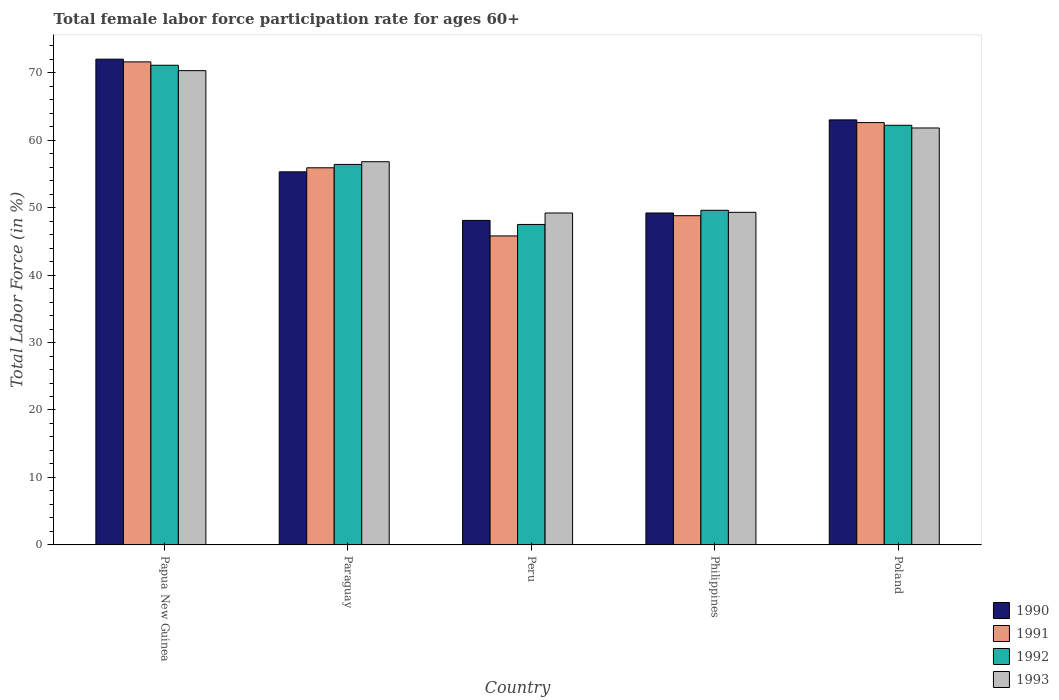How many different coloured bars are there?
Your answer should be very brief. 4. How many groups of bars are there?
Your answer should be very brief. 5. Are the number of bars per tick equal to the number of legend labels?
Offer a very short reply. Yes. How many bars are there on the 2nd tick from the left?
Provide a succinct answer. 4. What is the label of the 4th group of bars from the left?
Your answer should be compact. Philippines. In how many cases, is the number of bars for a given country not equal to the number of legend labels?
Give a very brief answer. 0. What is the female labor force participation rate in 1992 in Philippines?
Your answer should be very brief. 49.6. Across all countries, what is the maximum female labor force participation rate in 1993?
Offer a terse response. 70.3. Across all countries, what is the minimum female labor force participation rate in 1991?
Keep it short and to the point. 45.8. In which country was the female labor force participation rate in 1990 maximum?
Ensure brevity in your answer.  Papua New Guinea. In which country was the female labor force participation rate in 1991 minimum?
Give a very brief answer. Peru. What is the total female labor force participation rate in 1993 in the graph?
Ensure brevity in your answer.  287.4. What is the difference between the female labor force participation rate in 1992 in Papua New Guinea and that in Philippines?
Make the answer very short. 21.5. What is the difference between the female labor force participation rate in 1990 in Philippines and the female labor force participation rate in 1992 in Paraguay?
Your answer should be very brief. -7.2. What is the average female labor force participation rate in 1991 per country?
Give a very brief answer. 56.94. What is the difference between the female labor force participation rate of/in 1991 and female labor force participation rate of/in 1993 in Poland?
Make the answer very short. 0.8. What is the ratio of the female labor force participation rate in 1991 in Peru to that in Philippines?
Ensure brevity in your answer.  0.94. Is the female labor force participation rate in 1993 in Peru less than that in Philippines?
Provide a succinct answer. Yes. What is the difference between the highest and the lowest female labor force participation rate in 1990?
Ensure brevity in your answer.  23.9. Does the graph contain any zero values?
Provide a succinct answer. No. Does the graph contain grids?
Your answer should be very brief. No. Where does the legend appear in the graph?
Your response must be concise. Bottom right. How are the legend labels stacked?
Keep it short and to the point. Vertical. What is the title of the graph?
Your answer should be very brief. Total female labor force participation rate for ages 60+. What is the Total Labor Force (in %) in 1991 in Papua New Guinea?
Provide a succinct answer. 71.6. What is the Total Labor Force (in %) in 1992 in Papua New Guinea?
Your answer should be very brief. 71.1. What is the Total Labor Force (in %) of 1993 in Papua New Guinea?
Your answer should be very brief. 70.3. What is the Total Labor Force (in %) in 1990 in Paraguay?
Offer a terse response. 55.3. What is the Total Labor Force (in %) of 1991 in Paraguay?
Provide a short and direct response. 55.9. What is the Total Labor Force (in %) of 1992 in Paraguay?
Make the answer very short. 56.4. What is the Total Labor Force (in %) in 1993 in Paraguay?
Give a very brief answer. 56.8. What is the Total Labor Force (in %) of 1990 in Peru?
Your response must be concise. 48.1. What is the Total Labor Force (in %) of 1991 in Peru?
Give a very brief answer. 45.8. What is the Total Labor Force (in %) in 1992 in Peru?
Your response must be concise. 47.5. What is the Total Labor Force (in %) in 1993 in Peru?
Provide a succinct answer. 49.2. What is the Total Labor Force (in %) in 1990 in Philippines?
Offer a very short reply. 49.2. What is the Total Labor Force (in %) in 1991 in Philippines?
Give a very brief answer. 48.8. What is the Total Labor Force (in %) of 1992 in Philippines?
Keep it short and to the point. 49.6. What is the Total Labor Force (in %) of 1993 in Philippines?
Provide a succinct answer. 49.3. What is the Total Labor Force (in %) of 1991 in Poland?
Keep it short and to the point. 62.6. What is the Total Labor Force (in %) of 1992 in Poland?
Your answer should be very brief. 62.2. What is the Total Labor Force (in %) of 1993 in Poland?
Give a very brief answer. 61.8. Across all countries, what is the maximum Total Labor Force (in %) in 1991?
Make the answer very short. 71.6. Across all countries, what is the maximum Total Labor Force (in %) of 1992?
Offer a very short reply. 71.1. Across all countries, what is the maximum Total Labor Force (in %) of 1993?
Give a very brief answer. 70.3. Across all countries, what is the minimum Total Labor Force (in %) in 1990?
Your response must be concise. 48.1. Across all countries, what is the minimum Total Labor Force (in %) in 1991?
Keep it short and to the point. 45.8. Across all countries, what is the minimum Total Labor Force (in %) in 1992?
Give a very brief answer. 47.5. Across all countries, what is the minimum Total Labor Force (in %) in 1993?
Offer a terse response. 49.2. What is the total Total Labor Force (in %) of 1990 in the graph?
Provide a short and direct response. 287.6. What is the total Total Labor Force (in %) in 1991 in the graph?
Offer a terse response. 284.7. What is the total Total Labor Force (in %) of 1992 in the graph?
Provide a short and direct response. 286.8. What is the total Total Labor Force (in %) of 1993 in the graph?
Keep it short and to the point. 287.4. What is the difference between the Total Labor Force (in %) of 1990 in Papua New Guinea and that in Peru?
Give a very brief answer. 23.9. What is the difference between the Total Labor Force (in %) in 1991 in Papua New Guinea and that in Peru?
Give a very brief answer. 25.8. What is the difference between the Total Labor Force (in %) in 1992 in Papua New Guinea and that in Peru?
Your response must be concise. 23.6. What is the difference between the Total Labor Force (in %) in 1993 in Papua New Guinea and that in Peru?
Your answer should be compact. 21.1. What is the difference between the Total Labor Force (in %) of 1990 in Papua New Guinea and that in Philippines?
Your answer should be compact. 22.8. What is the difference between the Total Labor Force (in %) in 1991 in Papua New Guinea and that in Philippines?
Provide a short and direct response. 22.8. What is the difference between the Total Labor Force (in %) in 1993 in Papua New Guinea and that in Philippines?
Your answer should be compact. 21. What is the difference between the Total Labor Force (in %) in 1991 in Paraguay and that in Peru?
Ensure brevity in your answer.  10.1. What is the difference between the Total Labor Force (in %) of 1990 in Paraguay and that in Philippines?
Ensure brevity in your answer.  6.1. What is the difference between the Total Labor Force (in %) of 1992 in Paraguay and that in Philippines?
Your answer should be very brief. 6.8. What is the difference between the Total Labor Force (in %) of 1993 in Paraguay and that in Philippines?
Your answer should be very brief. 7.5. What is the difference between the Total Labor Force (in %) of 1991 in Paraguay and that in Poland?
Provide a short and direct response. -6.7. What is the difference between the Total Labor Force (in %) of 1992 in Paraguay and that in Poland?
Your response must be concise. -5.8. What is the difference between the Total Labor Force (in %) of 1990 in Peru and that in Philippines?
Make the answer very short. -1.1. What is the difference between the Total Labor Force (in %) of 1992 in Peru and that in Philippines?
Give a very brief answer. -2.1. What is the difference between the Total Labor Force (in %) of 1993 in Peru and that in Philippines?
Your answer should be compact. -0.1. What is the difference between the Total Labor Force (in %) in 1990 in Peru and that in Poland?
Your answer should be compact. -14.9. What is the difference between the Total Labor Force (in %) of 1991 in Peru and that in Poland?
Your answer should be compact. -16.8. What is the difference between the Total Labor Force (in %) of 1992 in Peru and that in Poland?
Make the answer very short. -14.7. What is the difference between the Total Labor Force (in %) of 1993 in Peru and that in Poland?
Offer a very short reply. -12.6. What is the difference between the Total Labor Force (in %) in 1992 in Philippines and that in Poland?
Keep it short and to the point. -12.6. What is the difference between the Total Labor Force (in %) of 1990 in Papua New Guinea and the Total Labor Force (in %) of 1992 in Paraguay?
Provide a succinct answer. 15.6. What is the difference between the Total Labor Force (in %) in 1990 in Papua New Guinea and the Total Labor Force (in %) in 1993 in Paraguay?
Offer a very short reply. 15.2. What is the difference between the Total Labor Force (in %) of 1991 in Papua New Guinea and the Total Labor Force (in %) of 1993 in Paraguay?
Give a very brief answer. 14.8. What is the difference between the Total Labor Force (in %) in 1992 in Papua New Guinea and the Total Labor Force (in %) in 1993 in Paraguay?
Offer a terse response. 14.3. What is the difference between the Total Labor Force (in %) of 1990 in Papua New Guinea and the Total Labor Force (in %) of 1991 in Peru?
Keep it short and to the point. 26.2. What is the difference between the Total Labor Force (in %) of 1990 in Papua New Guinea and the Total Labor Force (in %) of 1993 in Peru?
Offer a very short reply. 22.8. What is the difference between the Total Labor Force (in %) in 1991 in Papua New Guinea and the Total Labor Force (in %) in 1992 in Peru?
Provide a succinct answer. 24.1. What is the difference between the Total Labor Force (in %) in 1991 in Papua New Guinea and the Total Labor Force (in %) in 1993 in Peru?
Your response must be concise. 22.4. What is the difference between the Total Labor Force (in %) in 1992 in Papua New Guinea and the Total Labor Force (in %) in 1993 in Peru?
Your answer should be compact. 21.9. What is the difference between the Total Labor Force (in %) in 1990 in Papua New Guinea and the Total Labor Force (in %) in 1991 in Philippines?
Your answer should be very brief. 23.2. What is the difference between the Total Labor Force (in %) of 1990 in Papua New Guinea and the Total Labor Force (in %) of 1992 in Philippines?
Make the answer very short. 22.4. What is the difference between the Total Labor Force (in %) of 1990 in Papua New Guinea and the Total Labor Force (in %) of 1993 in Philippines?
Give a very brief answer. 22.7. What is the difference between the Total Labor Force (in %) of 1991 in Papua New Guinea and the Total Labor Force (in %) of 1992 in Philippines?
Your answer should be compact. 22. What is the difference between the Total Labor Force (in %) of 1991 in Papua New Guinea and the Total Labor Force (in %) of 1993 in Philippines?
Keep it short and to the point. 22.3. What is the difference between the Total Labor Force (in %) in 1992 in Papua New Guinea and the Total Labor Force (in %) in 1993 in Philippines?
Offer a terse response. 21.8. What is the difference between the Total Labor Force (in %) of 1990 in Papua New Guinea and the Total Labor Force (in %) of 1992 in Poland?
Your answer should be very brief. 9.8. What is the difference between the Total Labor Force (in %) of 1992 in Papua New Guinea and the Total Labor Force (in %) of 1993 in Poland?
Provide a short and direct response. 9.3. What is the difference between the Total Labor Force (in %) in 1990 in Paraguay and the Total Labor Force (in %) in 1993 in Peru?
Your answer should be very brief. 6.1. What is the difference between the Total Labor Force (in %) of 1990 in Paraguay and the Total Labor Force (in %) of 1991 in Philippines?
Make the answer very short. 6.5. What is the difference between the Total Labor Force (in %) of 1990 in Paraguay and the Total Labor Force (in %) of 1992 in Philippines?
Ensure brevity in your answer.  5.7. What is the difference between the Total Labor Force (in %) in 1990 in Paraguay and the Total Labor Force (in %) in 1993 in Philippines?
Your response must be concise. 6. What is the difference between the Total Labor Force (in %) in 1991 in Paraguay and the Total Labor Force (in %) in 1992 in Philippines?
Your response must be concise. 6.3. What is the difference between the Total Labor Force (in %) of 1991 in Paraguay and the Total Labor Force (in %) of 1993 in Philippines?
Ensure brevity in your answer.  6.6. What is the difference between the Total Labor Force (in %) in 1990 in Paraguay and the Total Labor Force (in %) in 1991 in Poland?
Your response must be concise. -7.3. What is the difference between the Total Labor Force (in %) in 1990 in Paraguay and the Total Labor Force (in %) in 1993 in Poland?
Your answer should be very brief. -6.5. What is the difference between the Total Labor Force (in %) in 1991 in Paraguay and the Total Labor Force (in %) in 1992 in Poland?
Offer a very short reply. -6.3. What is the difference between the Total Labor Force (in %) of 1991 in Paraguay and the Total Labor Force (in %) of 1993 in Poland?
Your response must be concise. -5.9. What is the difference between the Total Labor Force (in %) in 1992 in Paraguay and the Total Labor Force (in %) in 1993 in Poland?
Provide a short and direct response. -5.4. What is the difference between the Total Labor Force (in %) of 1990 in Peru and the Total Labor Force (in %) of 1991 in Philippines?
Offer a terse response. -0.7. What is the difference between the Total Labor Force (in %) in 1990 in Peru and the Total Labor Force (in %) in 1992 in Philippines?
Make the answer very short. -1.5. What is the difference between the Total Labor Force (in %) in 1990 in Peru and the Total Labor Force (in %) in 1993 in Philippines?
Offer a very short reply. -1.2. What is the difference between the Total Labor Force (in %) of 1991 in Peru and the Total Labor Force (in %) of 1992 in Philippines?
Your response must be concise. -3.8. What is the difference between the Total Labor Force (in %) in 1991 in Peru and the Total Labor Force (in %) in 1993 in Philippines?
Your answer should be compact. -3.5. What is the difference between the Total Labor Force (in %) in 1990 in Peru and the Total Labor Force (in %) in 1992 in Poland?
Offer a terse response. -14.1. What is the difference between the Total Labor Force (in %) in 1990 in Peru and the Total Labor Force (in %) in 1993 in Poland?
Offer a very short reply. -13.7. What is the difference between the Total Labor Force (in %) in 1991 in Peru and the Total Labor Force (in %) in 1992 in Poland?
Your answer should be compact. -16.4. What is the difference between the Total Labor Force (in %) in 1991 in Peru and the Total Labor Force (in %) in 1993 in Poland?
Give a very brief answer. -16. What is the difference between the Total Labor Force (in %) in 1992 in Peru and the Total Labor Force (in %) in 1993 in Poland?
Offer a terse response. -14.3. What is the difference between the Total Labor Force (in %) in 1990 in Philippines and the Total Labor Force (in %) in 1991 in Poland?
Ensure brevity in your answer.  -13.4. What is the difference between the Total Labor Force (in %) of 1990 in Philippines and the Total Labor Force (in %) of 1992 in Poland?
Keep it short and to the point. -13. What is the difference between the Total Labor Force (in %) in 1990 in Philippines and the Total Labor Force (in %) in 1993 in Poland?
Keep it short and to the point. -12.6. What is the average Total Labor Force (in %) in 1990 per country?
Provide a short and direct response. 57.52. What is the average Total Labor Force (in %) in 1991 per country?
Your response must be concise. 56.94. What is the average Total Labor Force (in %) of 1992 per country?
Provide a succinct answer. 57.36. What is the average Total Labor Force (in %) in 1993 per country?
Give a very brief answer. 57.48. What is the difference between the Total Labor Force (in %) in 1991 and Total Labor Force (in %) in 1993 in Papua New Guinea?
Provide a succinct answer. 1.3. What is the difference between the Total Labor Force (in %) of 1990 and Total Labor Force (in %) of 1991 in Paraguay?
Ensure brevity in your answer.  -0.6. What is the difference between the Total Labor Force (in %) of 1990 and Total Labor Force (in %) of 1992 in Paraguay?
Provide a short and direct response. -1.1. What is the difference between the Total Labor Force (in %) of 1990 and Total Labor Force (in %) of 1993 in Paraguay?
Give a very brief answer. -1.5. What is the difference between the Total Labor Force (in %) in 1991 and Total Labor Force (in %) in 1993 in Philippines?
Your response must be concise. -0.5. What is the difference between the Total Labor Force (in %) in 1992 and Total Labor Force (in %) in 1993 in Philippines?
Offer a terse response. 0.3. What is the difference between the Total Labor Force (in %) in 1990 and Total Labor Force (in %) in 1991 in Poland?
Keep it short and to the point. 0.4. What is the difference between the Total Labor Force (in %) in 1990 and Total Labor Force (in %) in 1992 in Poland?
Give a very brief answer. 0.8. What is the difference between the Total Labor Force (in %) in 1990 and Total Labor Force (in %) in 1993 in Poland?
Keep it short and to the point. 1.2. What is the difference between the Total Labor Force (in %) of 1991 and Total Labor Force (in %) of 1992 in Poland?
Ensure brevity in your answer.  0.4. What is the difference between the Total Labor Force (in %) of 1992 and Total Labor Force (in %) of 1993 in Poland?
Provide a succinct answer. 0.4. What is the ratio of the Total Labor Force (in %) of 1990 in Papua New Guinea to that in Paraguay?
Your answer should be very brief. 1.3. What is the ratio of the Total Labor Force (in %) of 1991 in Papua New Guinea to that in Paraguay?
Offer a terse response. 1.28. What is the ratio of the Total Labor Force (in %) of 1992 in Papua New Guinea to that in Paraguay?
Offer a terse response. 1.26. What is the ratio of the Total Labor Force (in %) in 1993 in Papua New Guinea to that in Paraguay?
Keep it short and to the point. 1.24. What is the ratio of the Total Labor Force (in %) of 1990 in Papua New Guinea to that in Peru?
Provide a succinct answer. 1.5. What is the ratio of the Total Labor Force (in %) of 1991 in Papua New Guinea to that in Peru?
Give a very brief answer. 1.56. What is the ratio of the Total Labor Force (in %) of 1992 in Papua New Guinea to that in Peru?
Make the answer very short. 1.5. What is the ratio of the Total Labor Force (in %) in 1993 in Papua New Guinea to that in Peru?
Provide a short and direct response. 1.43. What is the ratio of the Total Labor Force (in %) in 1990 in Papua New Guinea to that in Philippines?
Your response must be concise. 1.46. What is the ratio of the Total Labor Force (in %) of 1991 in Papua New Guinea to that in Philippines?
Provide a short and direct response. 1.47. What is the ratio of the Total Labor Force (in %) in 1992 in Papua New Guinea to that in Philippines?
Ensure brevity in your answer.  1.43. What is the ratio of the Total Labor Force (in %) of 1993 in Papua New Guinea to that in Philippines?
Your answer should be very brief. 1.43. What is the ratio of the Total Labor Force (in %) of 1990 in Papua New Guinea to that in Poland?
Offer a very short reply. 1.14. What is the ratio of the Total Labor Force (in %) in 1991 in Papua New Guinea to that in Poland?
Your response must be concise. 1.14. What is the ratio of the Total Labor Force (in %) in 1992 in Papua New Guinea to that in Poland?
Give a very brief answer. 1.14. What is the ratio of the Total Labor Force (in %) in 1993 in Papua New Guinea to that in Poland?
Your answer should be very brief. 1.14. What is the ratio of the Total Labor Force (in %) of 1990 in Paraguay to that in Peru?
Provide a succinct answer. 1.15. What is the ratio of the Total Labor Force (in %) of 1991 in Paraguay to that in Peru?
Offer a terse response. 1.22. What is the ratio of the Total Labor Force (in %) in 1992 in Paraguay to that in Peru?
Your answer should be compact. 1.19. What is the ratio of the Total Labor Force (in %) of 1993 in Paraguay to that in Peru?
Your answer should be very brief. 1.15. What is the ratio of the Total Labor Force (in %) in 1990 in Paraguay to that in Philippines?
Provide a succinct answer. 1.12. What is the ratio of the Total Labor Force (in %) of 1991 in Paraguay to that in Philippines?
Give a very brief answer. 1.15. What is the ratio of the Total Labor Force (in %) in 1992 in Paraguay to that in Philippines?
Offer a very short reply. 1.14. What is the ratio of the Total Labor Force (in %) of 1993 in Paraguay to that in Philippines?
Give a very brief answer. 1.15. What is the ratio of the Total Labor Force (in %) in 1990 in Paraguay to that in Poland?
Your answer should be compact. 0.88. What is the ratio of the Total Labor Force (in %) in 1991 in Paraguay to that in Poland?
Offer a terse response. 0.89. What is the ratio of the Total Labor Force (in %) of 1992 in Paraguay to that in Poland?
Provide a short and direct response. 0.91. What is the ratio of the Total Labor Force (in %) in 1993 in Paraguay to that in Poland?
Keep it short and to the point. 0.92. What is the ratio of the Total Labor Force (in %) of 1990 in Peru to that in Philippines?
Your answer should be very brief. 0.98. What is the ratio of the Total Labor Force (in %) of 1991 in Peru to that in Philippines?
Your response must be concise. 0.94. What is the ratio of the Total Labor Force (in %) in 1992 in Peru to that in Philippines?
Offer a terse response. 0.96. What is the ratio of the Total Labor Force (in %) of 1990 in Peru to that in Poland?
Provide a short and direct response. 0.76. What is the ratio of the Total Labor Force (in %) of 1991 in Peru to that in Poland?
Provide a short and direct response. 0.73. What is the ratio of the Total Labor Force (in %) of 1992 in Peru to that in Poland?
Offer a very short reply. 0.76. What is the ratio of the Total Labor Force (in %) in 1993 in Peru to that in Poland?
Make the answer very short. 0.8. What is the ratio of the Total Labor Force (in %) of 1990 in Philippines to that in Poland?
Ensure brevity in your answer.  0.78. What is the ratio of the Total Labor Force (in %) in 1991 in Philippines to that in Poland?
Your answer should be compact. 0.78. What is the ratio of the Total Labor Force (in %) in 1992 in Philippines to that in Poland?
Your response must be concise. 0.8. What is the ratio of the Total Labor Force (in %) in 1993 in Philippines to that in Poland?
Give a very brief answer. 0.8. What is the difference between the highest and the second highest Total Labor Force (in %) of 1992?
Ensure brevity in your answer.  8.9. What is the difference between the highest and the lowest Total Labor Force (in %) in 1990?
Your answer should be very brief. 23.9. What is the difference between the highest and the lowest Total Labor Force (in %) of 1991?
Offer a very short reply. 25.8. What is the difference between the highest and the lowest Total Labor Force (in %) of 1992?
Give a very brief answer. 23.6. What is the difference between the highest and the lowest Total Labor Force (in %) of 1993?
Provide a succinct answer. 21.1. 